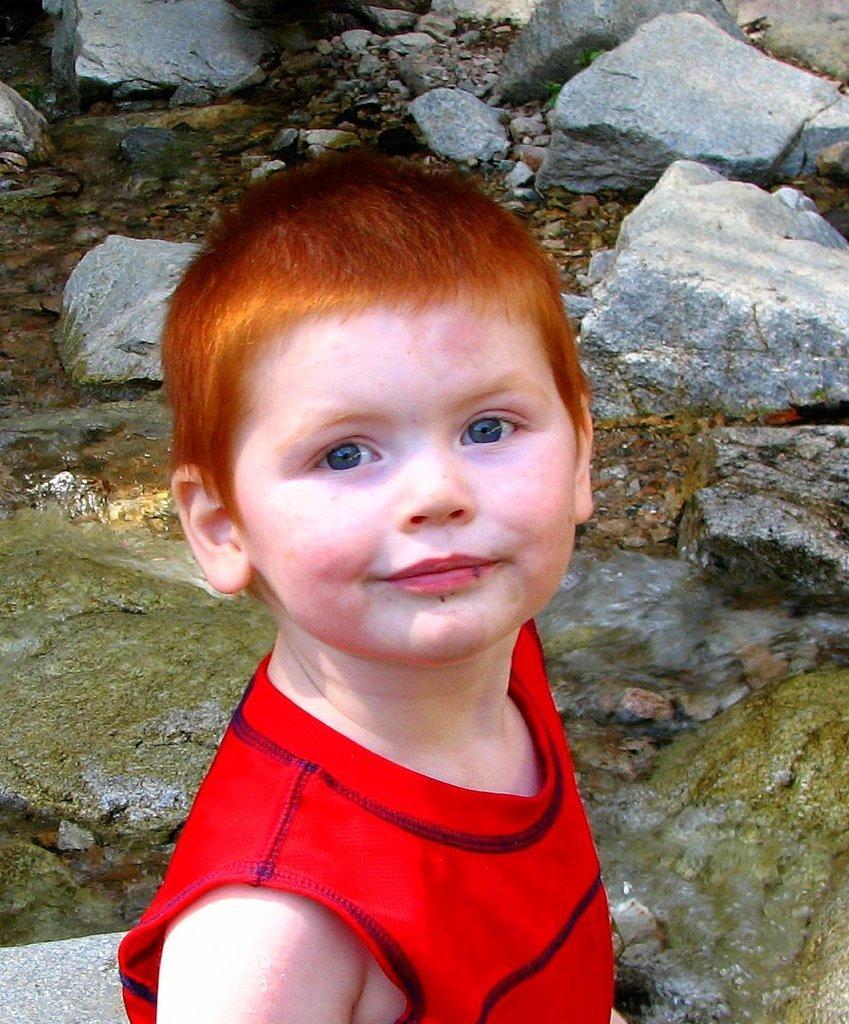Describe this image in one or two sentences. In this image we can see a kid. In the background, we can see the stones. 